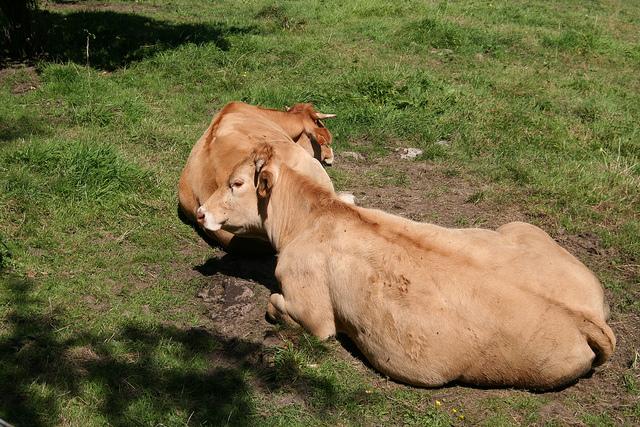What is in the field?
Be succinct. Cows. Is the cow in the background actually smaller?
Write a very short answer. No. What color is the cow?
Answer briefly. Brown. Do the animals look tired?
Quick response, please. Yes. According to most variations of the song, does Old McDonald have some of these?
Keep it brief. Yes. 